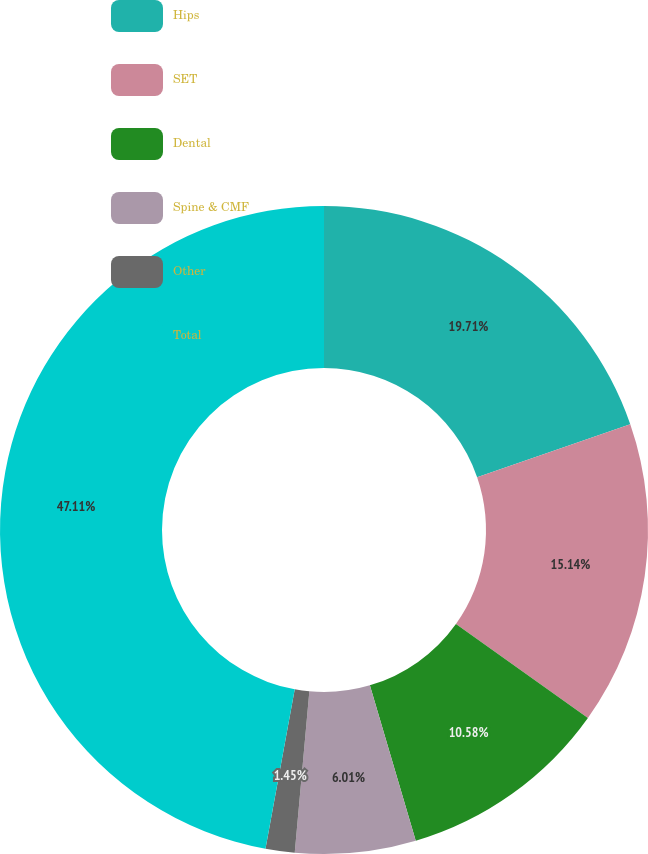Convert chart to OTSL. <chart><loc_0><loc_0><loc_500><loc_500><pie_chart><fcel>Hips<fcel>SET<fcel>Dental<fcel>Spine & CMF<fcel>Other<fcel>Total<nl><fcel>19.71%<fcel>15.14%<fcel>10.58%<fcel>6.01%<fcel>1.45%<fcel>47.11%<nl></chart> 